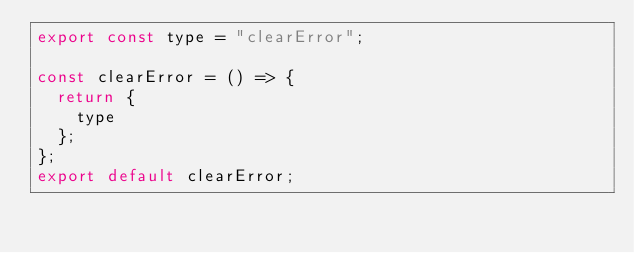<code> <loc_0><loc_0><loc_500><loc_500><_JavaScript_>export const type = "clearError";

const clearError = () => {
  return {
    type
  };
};
export default clearError;
</code> 